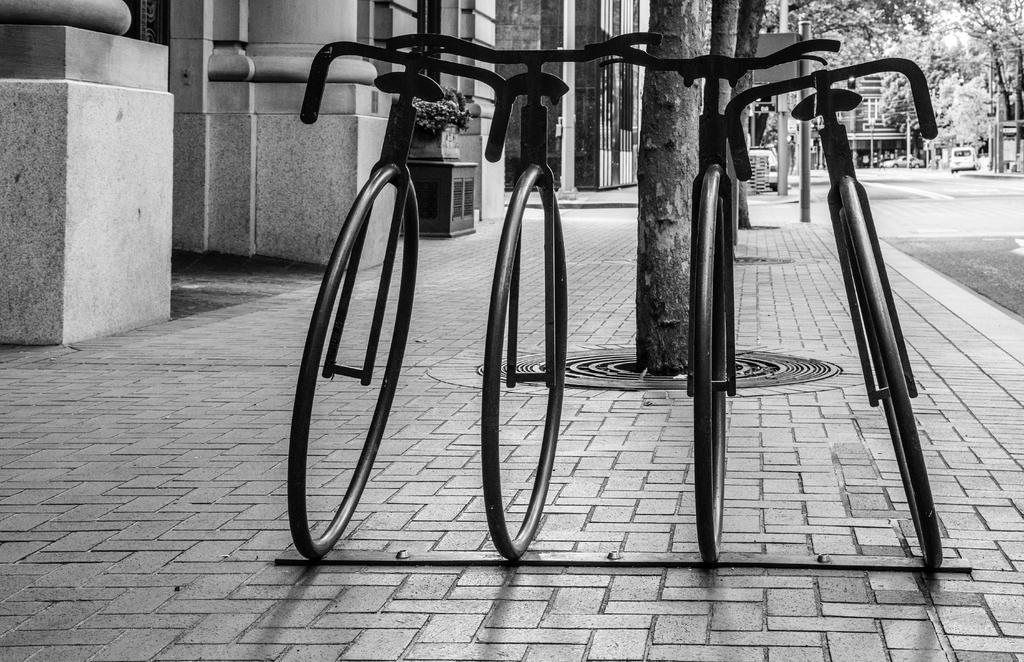Could you give a brief overview of what you see in this image? This is a black and white image. There are four unicycles. I can see the trees. These are the buildings with pillars. This looks like a flower pot with a plant, which is placed on the wooden box. This is the road. In the background, I can see the cars on the road. 